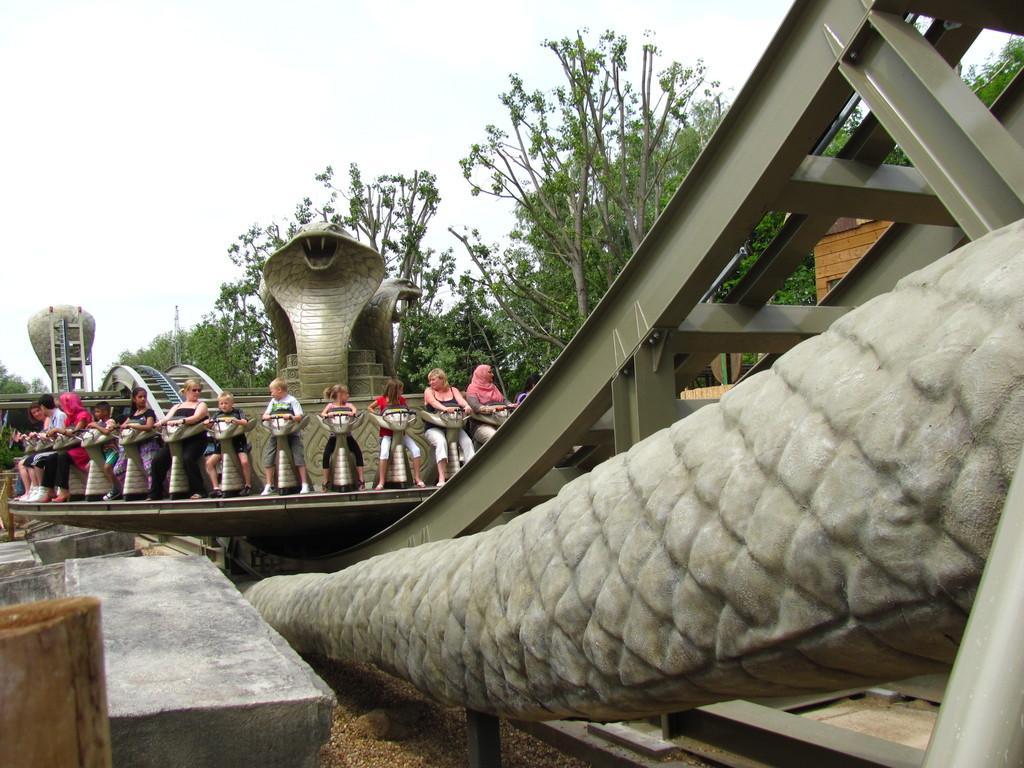Describe this image in one or two sentences. In the image there are some people taking an amusement ride, behind the ride there are trees. 